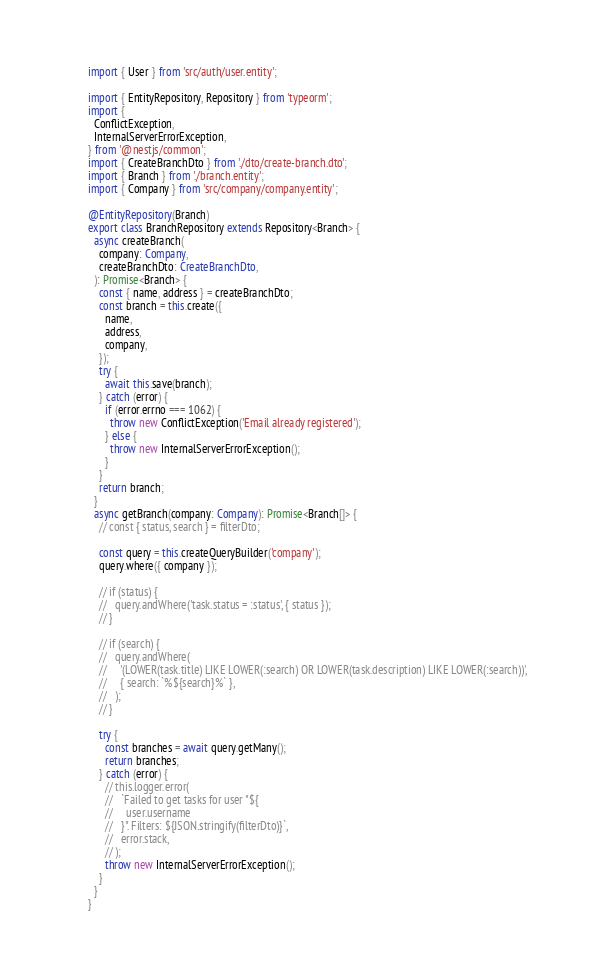Convert code to text. <code><loc_0><loc_0><loc_500><loc_500><_TypeScript_>import { User } from 'src/auth/user.entity';

import { EntityRepository, Repository } from 'typeorm';
import {
  ConflictException,
  InternalServerErrorException,
} from '@nestjs/common';
import { CreateBranchDto } from './dto/create-branch.dto';
import { Branch } from './branch.entity';
import { Company } from 'src/company/company.entity';

@EntityRepository(Branch)
export class BranchRepository extends Repository<Branch> {
  async createBranch(
    company: Company,
    createBranchDto: CreateBranchDto,
  ): Promise<Branch> {
    const { name, address } = createBranchDto;
    const branch = this.create({
      name,
      address,
      company,
    });
    try {
      await this.save(branch);
    } catch (error) {
      if (error.errno === 1062) {
        throw new ConflictException('Email already registered');
      } else {
        throw new InternalServerErrorException();
      }
    }
    return branch;
  }
  async getBranch(company: Company): Promise<Branch[]> {
    // const { status, search } = filterDto;

    const query = this.createQueryBuilder('company');
    query.where({ company });

    // if (status) {
    //   query.andWhere('task.status = :status', { status });
    // }

    // if (search) {
    //   query.andWhere(
    //     '(LOWER(task.title) LIKE LOWER(:search) OR LOWER(task.description) LIKE LOWER(:search))',
    //     { search: `%${search}%` },
    //   );
    // }

    try {
      const branches = await query.getMany();
      return branches;
    } catch (error) {
      // this.logger.error(
      //   `Failed to get tasks for user "${
      //     user.username
      //   }". Filters: ${JSON.stringify(filterDto)}`,
      //   error.stack,
      // );
      throw new InternalServerErrorException();
    }
  }
}
</code> 